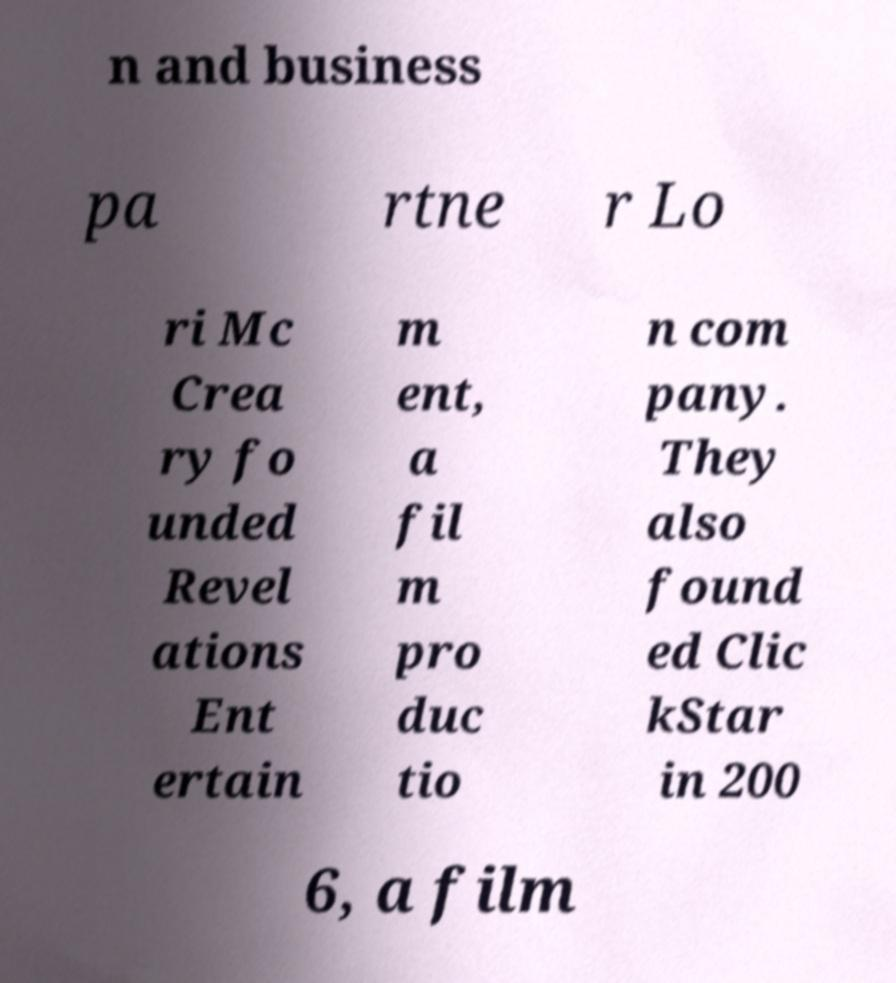Can you read and provide the text displayed in the image?This photo seems to have some interesting text. Can you extract and type it out for me? n and business pa rtne r Lo ri Mc Crea ry fo unded Revel ations Ent ertain m ent, a fil m pro duc tio n com pany. They also found ed Clic kStar in 200 6, a film 